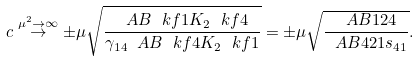Convert formula to latex. <formula><loc_0><loc_0><loc_500><loc_500>c \overset { \mu ^ { 2 } \to \infty } { \to } \pm \mu \sqrt { \frac { \ A B { \ k f 1 } { K _ { 2 } } { \ k f 4 } } { \gamma _ { 1 4 } \ A B { \ k f 4 } { K _ { 2 } } { \ k f 1 } } } = \pm \mu \sqrt { \frac { \ A B 1 2 4 } { \ A B 4 2 1 s _ { 4 1 } } } .</formula> 